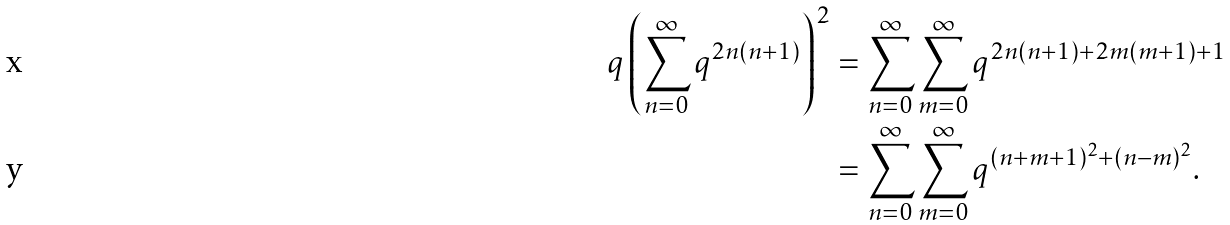<formula> <loc_0><loc_0><loc_500><loc_500>q \left ( \sum _ { n = 0 } ^ { \infty } q ^ { 2 n ( n + 1 ) } \right ) ^ { 2 } & = \sum _ { n = 0 } ^ { \infty } \sum _ { m = 0 } ^ { \infty } q ^ { 2 n ( n + 1 ) + 2 m ( m + 1 ) + 1 } \\ & = \sum _ { n = 0 } ^ { \infty } \sum _ { m = 0 } ^ { \infty } q ^ { ( n + m + 1 ) ^ { 2 } + ( n - m ) ^ { 2 } } .</formula> 